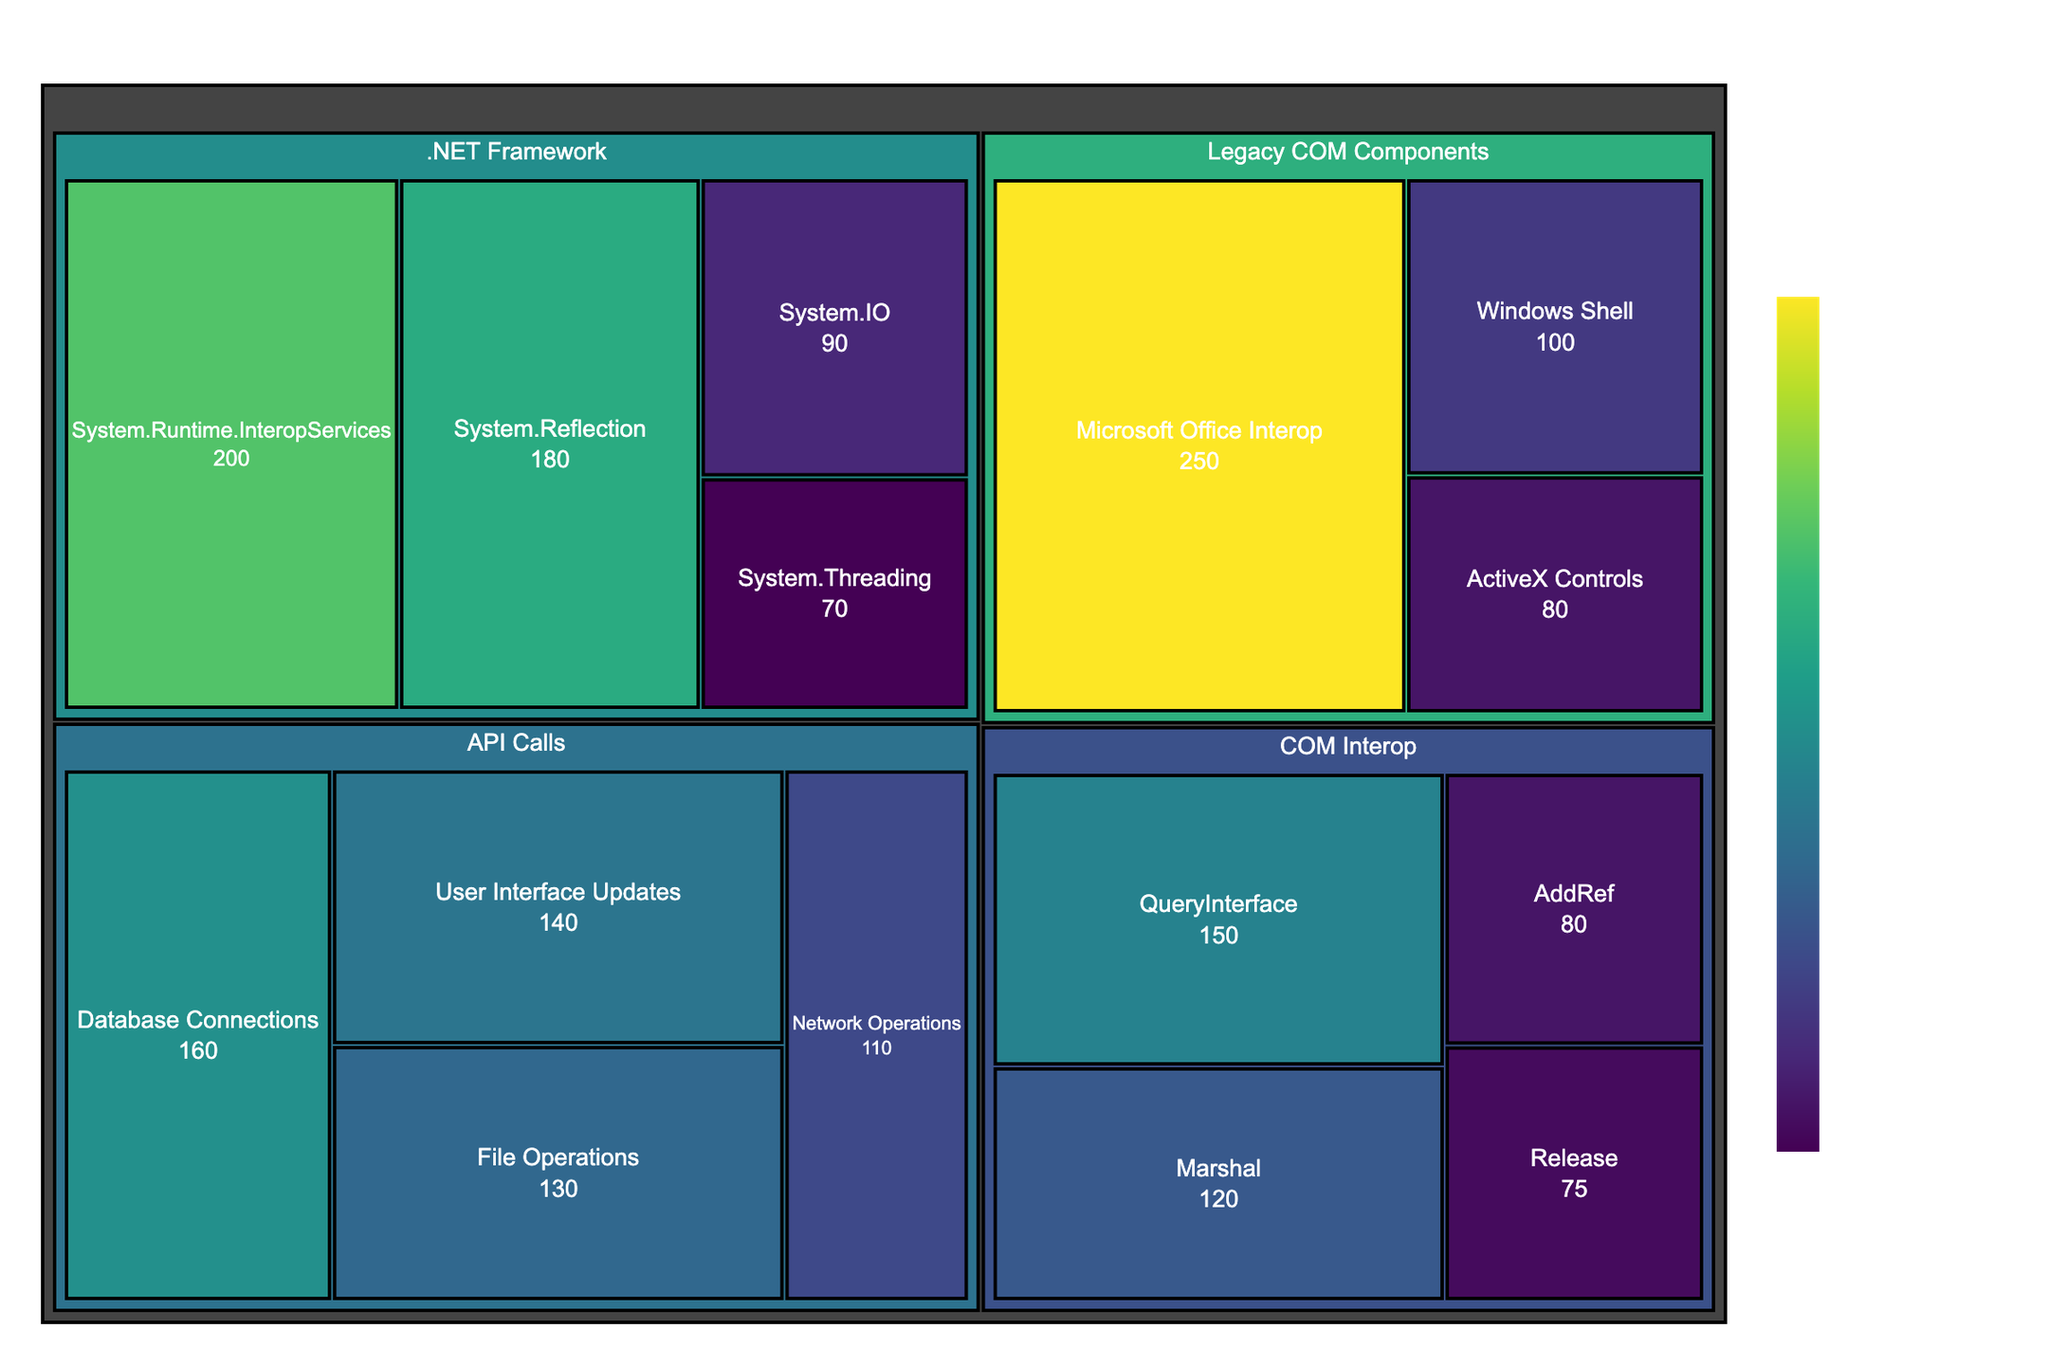what is the title of the treemap? The title of the treemap is displayed at the top of the figure. By looking there, you can see the title text.
Answer: Distribution of API Calls in .NET Application with COM Interop which subcategory under 'Legacy COM Components' has the highest value? Look under the 'Legacy COM Components' category, then compare the values of each subcategory to find the highest. The largest block size will help identify it.
Answer: Microsoft Office Interop what is the total value of 'COM Interop' category? Sum the values of all subcategories under the 'COM Interop' category: QueryInterface (150), AddRef (80), Release (75), and Marshal (120). 150 + 80 + 75 + 120 = 425
Answer: 425 how does 'System.IO' compare to 'File Operations' in terms of value? Compare the block sizes of 'System.IO' under '.NET Framework' with 'File Operations' under 'API Calls'. 'System.IO' has a value of 90, while 'File Operations' has a value of 130.
Answer: File Operations has a higher value what is the combined value for 'Database Connections' and 'User Interface Updates'? Add the values for 'Database Connections' (160) and 'User Interface Updates' (140). 160 + 140 = 300
Answer: 300 which category has the most subcategories and how many? Look at all main categories: 'COM Interop', '.NET Framework', 'Legacy COM Components', and 'API Calls'. Count the subcategories under each. '.NET Framework' has the most with 4 subcategories.
Answer: .NET Framework, 4 what proportion of the total value is contributed by the 'Microsoft Office Interop' subcategory? First, find the total value by summing all subcategories: 150+80+75+120+200+180+90+70+250+100+80+130+110+160+140 = 2135. Then, divide the 'Microsoft Office Interop' value (250) by the total and multiply by 100 to get the percentage: (250/2135) * 100 = 11.7%
Answer: 11.7% what subcategory has the smallest value and what is it? Compare the smallest values among all subcategories. 'Release' under 'COM Interop' has a value of 75, which is the smallest.
Answer: Release, 75 which has a higher frequency: 'System.Runtime.InteropServices' or 'Marshal'? Compare the values: 'System.Runtime.InteropServices' (200) and 'Marshal' (120). 'System.Runtime.InteropServices' is higher.
Answer: System.Runtime.InteropServices what is the color of the block representing 'Database Connections'? The color is represented using a continuous scale from the Viridis color palette. Since API calls like 'Database Connections' have a moderate to high frequency and are typically color-coded from green to yellow, 'Database Connections' is likely a greenish-yellow.
Answer: Greenish-yellow 